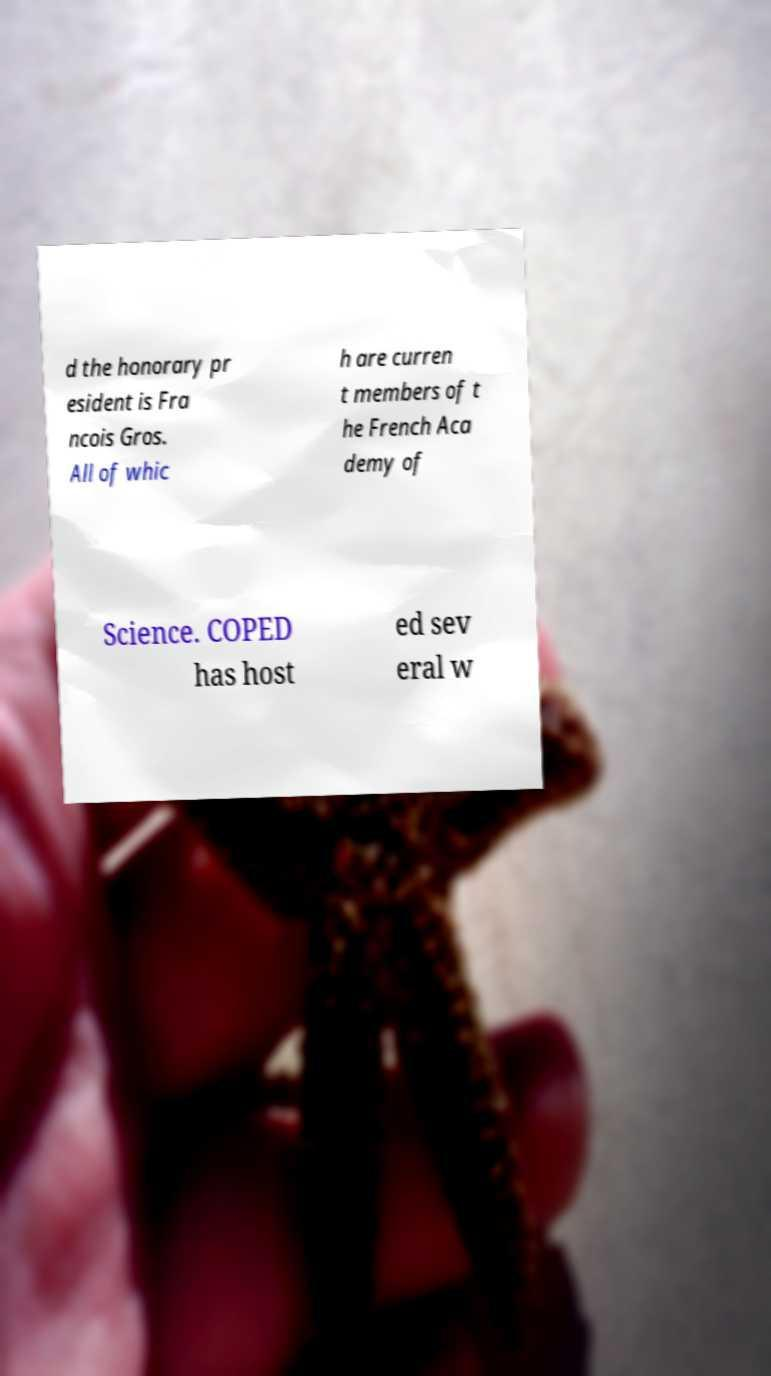Could you assist in decoding the text presented in this image and type it out clearly? d the honorary pr esident is Fra ncois Gros. All of whic h are curren t members of t he French Aca demy of Science. COPED has host ed sev eral w 